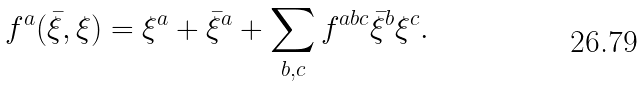Convert formula to latex. <formula><loc_0><loc_0><loc_500><loc_500>f ^ { a } ( { \bar { \xi } } , \xi ) = \xi ^ { a } + { \bar { \xi } } ^ { a } + \sum _ { b , c } f ^ { a b c } { \bar { \xi } } ^ { b } \xi ^ { c } .</formula> 